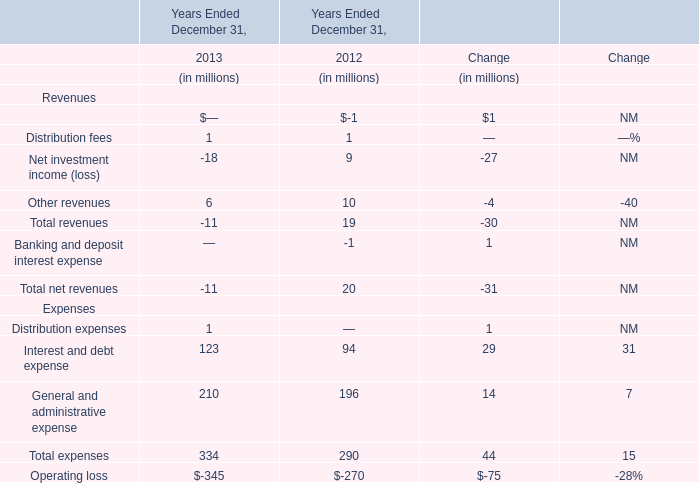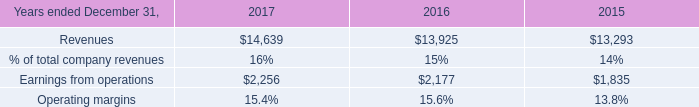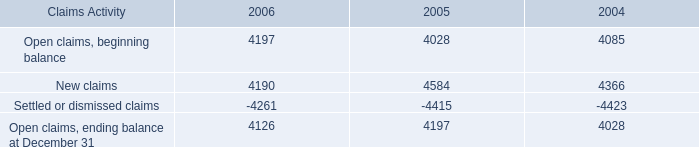what was the percentage change in open claims ending balance at december 31 from 2004 to 2005? 
Computations: ((4197 - 4028) / 4028)
Answer: 0.04196. 